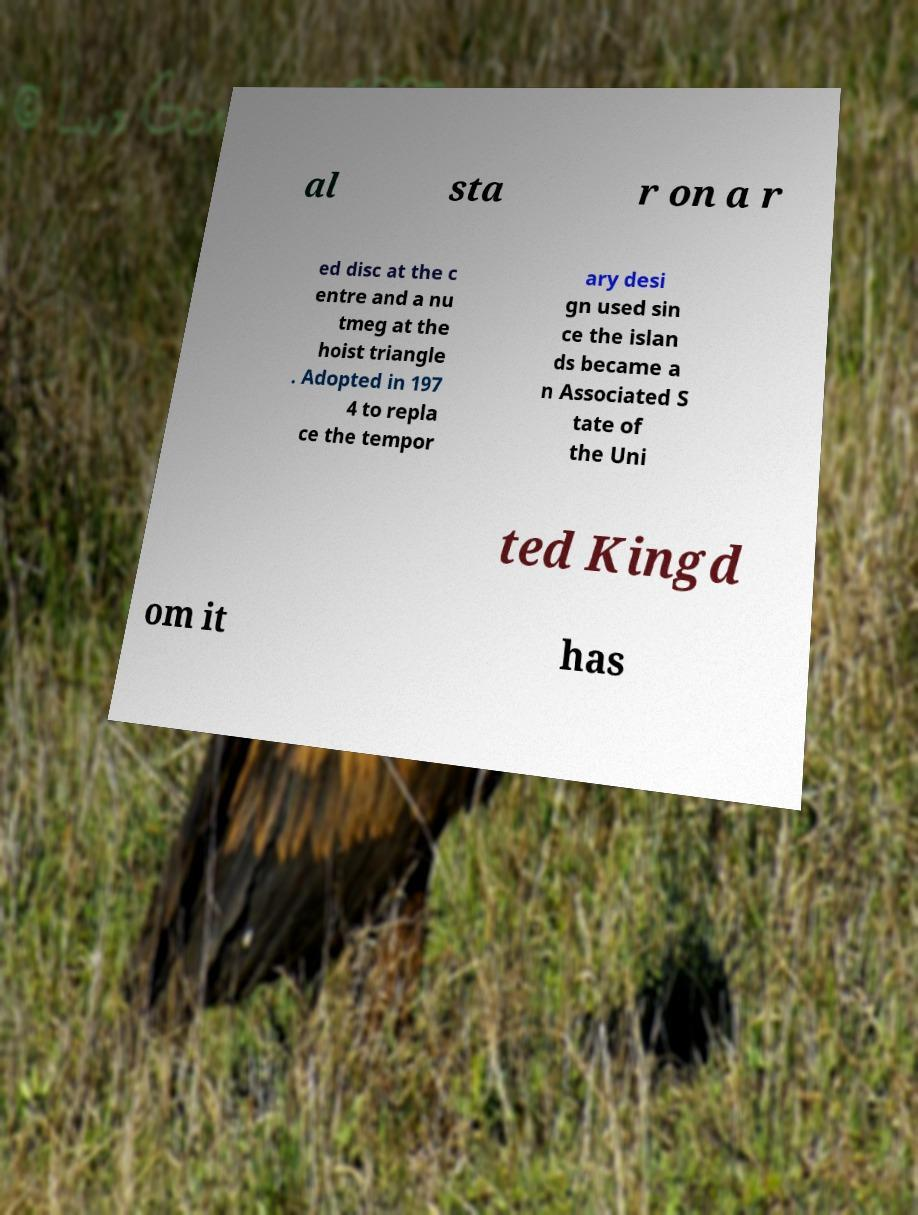Could you assist in decoding the text presented in this image and type it out clearly? al sta r on a r ed disc at the c entre and a nu tmeg at the hoist triangle . Adopted in 197 4 to repla ce the tempor ary desi gn used sin ce the islan ds became a n Associated S tate of the Uni ted Kingd om it has 